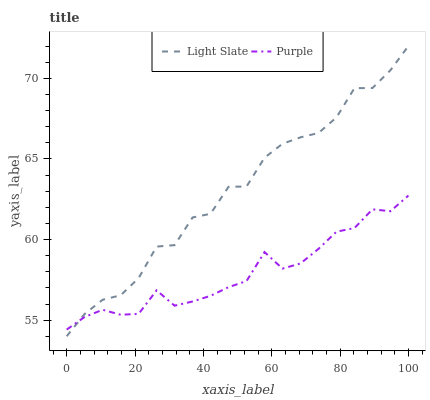Does Purple have the minimum area under the curve?
Answer yes or no. Yes. Does Light Slate have the maximum area under the curve?
Answer yes or no. Yes. Does Purple have the maximum area under the curve?
Answer yes or no. No. Is Purple the smoothest?
Answer yes or no. Yes. Is Light Slate the roughest?
Answer yes or no. Yes. Is Purple the roughest?
Answer yes or no. No. Does Purple have the lowest value?
Answer yes or no. No. Does Light Slate have the highest value?
Answer yes or no. Yes. Does Purple have the highest value?
Answer yes or no. No. Does Light Slate intersect Purple?
Answer yes or no. Yes. Is Light Slate less than Purple?
Answer yes or no. No. Is Light Slate greater than Purple?
Answer yes or no. No. 